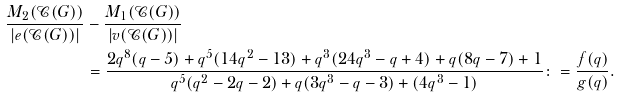<formula> <loc_0><loc_0><loc_500><loc_500>\frac { M _ { 2 } ( \mathcal { C } ( G ) ) } { | e ( \mathcal { C } ( G ) ) | } & - \frac { M _ { 1 } ( \mathcal { C } ( G ) ) } { | v ( \mathcal { C } ( G ) ) | } \\ & = \frac { 2 q ^ { 8 } ( q - 5 ) + q ^ { 5 } ( 1 4 q ^ { 2 } - 1 3 ) + q ^ { 3 } ( 2 4 q ^ { 3 } - q + 4 ) + q ( 8 q - 7 ) + 1 } { q ^ { 5 } ( q ^ { 2 } - 2 q - 2 ) + q ( 3 q ^ { 3 } - q - 3 ) + ( 4 q ^ { 3 } - 1 ) } \colon = \frac { f ( q ) } { g ( q ) } .</formula> 